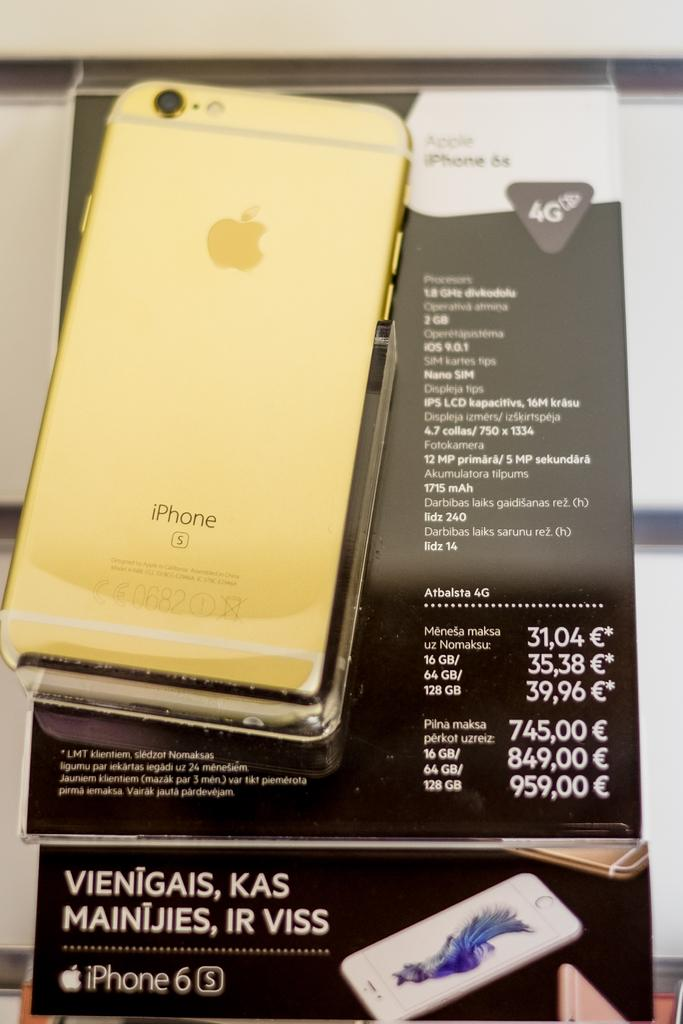<image>
Relay a brief, clear account of the picture shown. A golden iPhone sits on top of a box. 